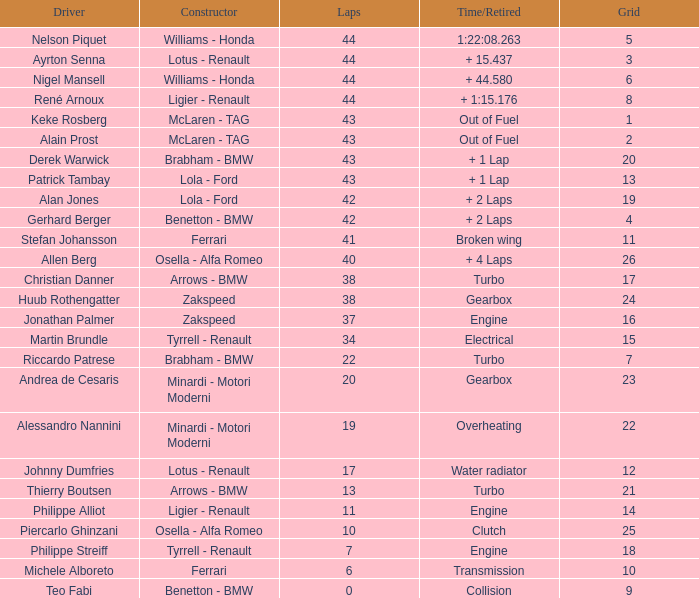I want the driver that has Laps of 10 Piercarlo Ghinzani. 